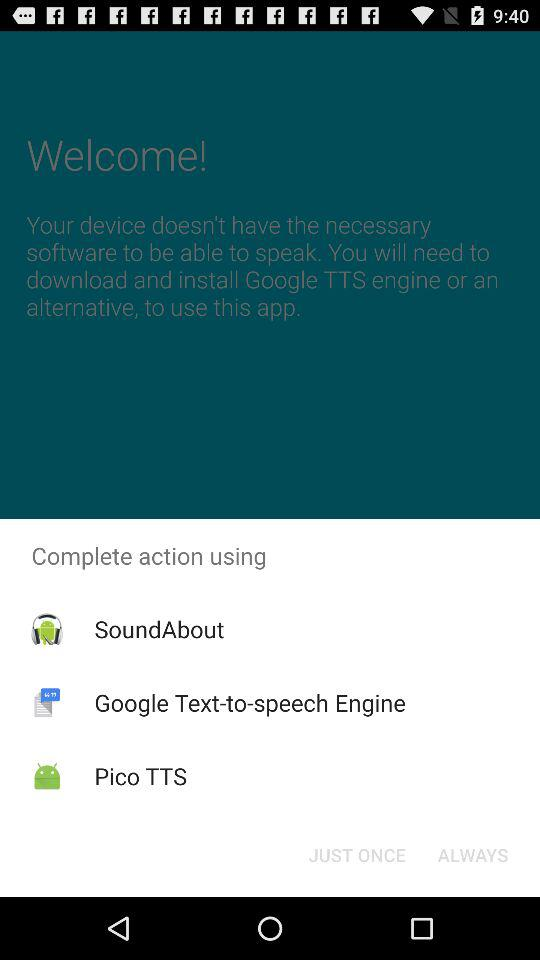How many TTS engines are available for download?
Answer the question using a single word or phrase. 3 